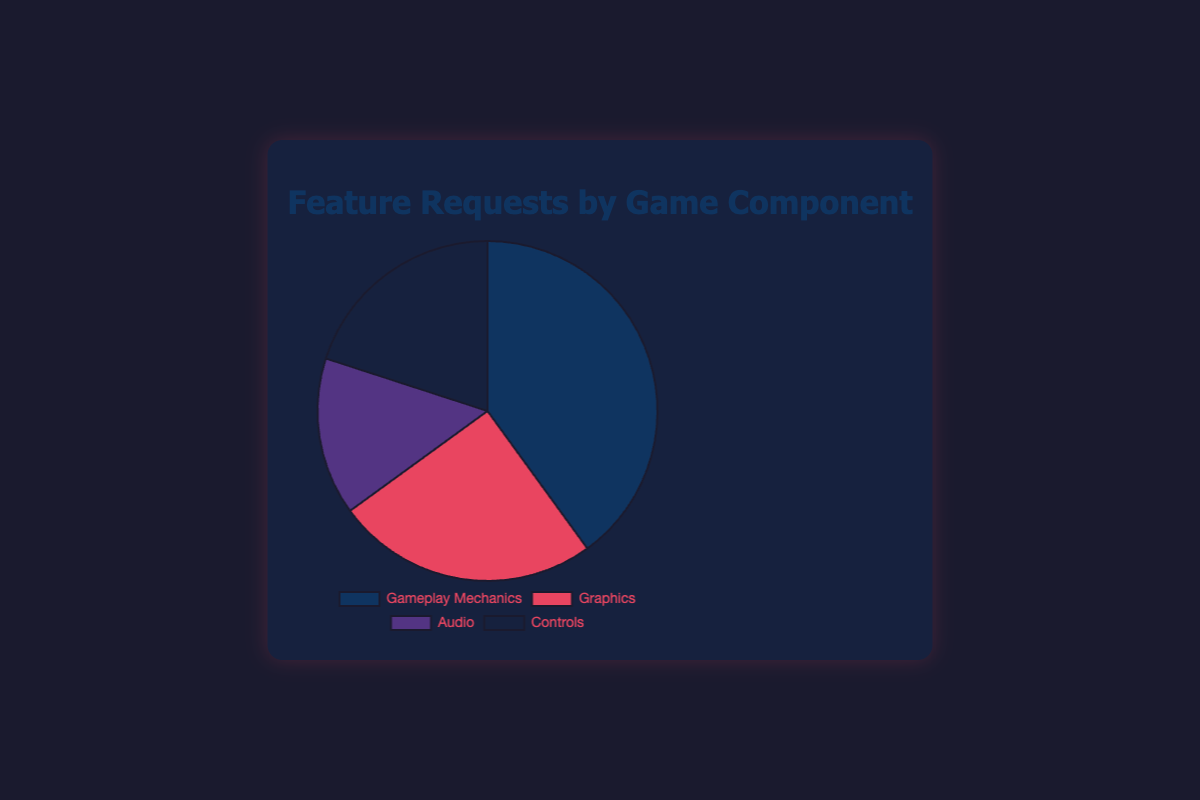What percentage does the sum of Graphics and Audio requests represent out of the total? Sum the percentages of Graphics and Audio requests: 25% (Graphics) + 15% (Audio) = 40%
Answer: 40% Which component has the highest percentage of feature requests? Gameplay Mechanics has the highest percentage of feature requests at 40%
Answer: Gameplay Mechanics Which two components together make up 60% of the feature requests? Gameplay Mechanics and Controls together make up 40% + 20% = 60%
Answer: Gameplay Mechanics and Controls What is the percentage difference between Controls and Audio feature requests? Subtract the percentage of Audio feature requests from Controls: 20% (Controls) - 15% (Audio) = 5%
Answer: 5% How many times greater are the feature requests for Gameplay Mechanics compared to Audio? Divide the percentage for Gameplay Mechanics by the percentage for Audio: 40% / 15% ≈ 2.67 times
Answer: 2.67 times Which component has a percentage closer to Controls, Graphics or Audio? The percentage for Graphics is 5% more than Controls, while Audio is 5% less than Controls, so they are equally close
Answer: Graphics and Audio Is the sum of feature requests for Graphics and Controls greater than those for Gameplay Mechanics? Sum the percentages of Graphics and Controls: 25% + 20% = 45%, which is greater than Gameplay Mechanics at 40%
Answer: Yes Considering all components, what is the average percentage of feature requests? Sum all percentages and divide by the number of components: (40% + 25% + 15% + 20%) / 4 = 100% / 4 = 25%
Answer: 25% Which component is represented by the color blue in the pie chart? Gameplay Mechanics is represented by the color blue
Answer: Gameplay Mechanics 